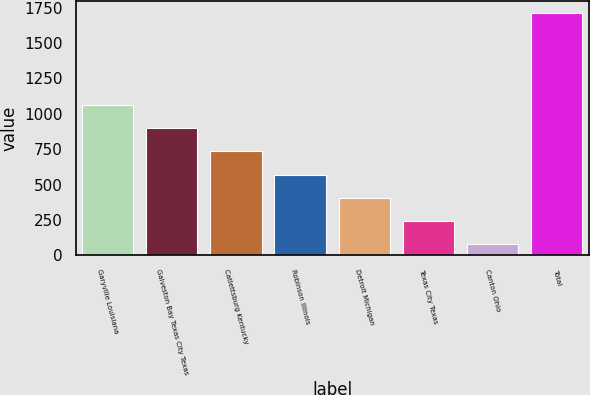Convert chart. <chart><loc_0><loc_0><loc_500><loc_500><bar_chart><fcel>Garyville Louisiana<fcel>Galveston Bay Texas City Texas<fcel>Catlettsburg Kentucky<fcel>Robinson Illinois<fcel>Detroit Michigan<fcel>Texas City Texas<fcel>Canton Ohio<fcel>Total<nl><fcel>1060.4<fcel>897<fcel>733.6<fcel>570.2<fcel>406.8<fcel>243.4<fcel>80<fcel>1714<nl></chart> 